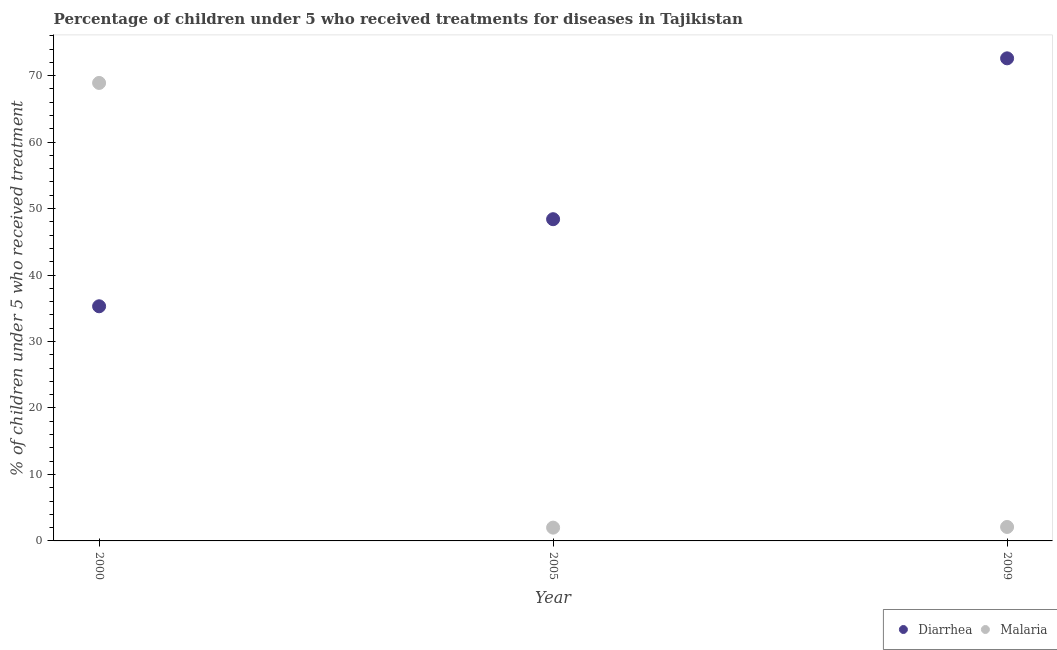What is the percentage of children who received treatment for malaria in 2009?
Keep it short and to the point. 2.1. Across all years, what is the maximum percentage of children who received treatment for diarrhoea?
Your answer should be very brief. 72.6. Across all years, what is the minimum percentage of children who received treatment for diarrhoea?
Keep it short and to the point. 35.3. In which year was the percentage of children who received treatment for diarrhoea minimum?
Ensure brevity in your answer.  2000. What is the total percentage of children who received treatment for diarrhoea in the graph?
Your answer should be compact. 156.3. What is the difference between the percentage of children who received treatment for diarrhoea in 2000 and that in 2009?
Your answer should be compact. -37.3. What is the difference between the percentage of children who received treatment for malaria in 2000 and the percentage of children who received treatment for diarrhoea in 2005?
Keep it short and to the point. 20.5. What is the average percentage of children who received treatment for malaria per year?
Give a very brief answer. 24.33. In the year 2009, what is the difference between the percentage of children who received treatment for malaria and percentage of children who received treatment for diarrhoea?
Offer a terse response. -70.5. What is the ratio of the percentage of children who received treatment for malaria in 2000 to that in 2005?
Keep it short and to the point. 34.45. Is the percentage of children who received treatment for malaria in 2000 less than that in 2005?
Give a very brief answer. No. What is the difference between the highest and the second highest percentage of children who received treatment for malaria?
Your response must be concise. 66.8. What is the difference between the highest and the lowest percentage of children who received treatment for malaria?
Your answer should be very brief. 66.9. Is the sum of the percentage of children who received treatment for diarrhoea in 2005 and 2009 greater than the maximum percentage of children who received treatment for malaria across all years?
Provide a succinct answer. Yes. Does the percentage of children who received treatment for diarrhoea monotonically increase over the years?
Ensure brevity in your answer.  Yes. Is the percentage of children who received treatment for malaria strictly greater than the percentage of children who received treatment for diarrhoea over the years?
Your answer should be very brief. No. How many dotlines are there?
Your response must be concise. 2. What is the difference between two consecutive major ticks on the Y-axis?
Provide a succinct answer. 10. How many legend labels are there?
Make the answer very short. 2. What is the title of the graph?
Offer a very short reply. Percentage of children under 5 who received treatments for diseases in Tajikistan. What is the label or title of the X-axis?
Offer a terse response. Year. What is the label or title of the Y-axis?
Your answer should be compact. % of children under 5 who received treatment. What is the % of children under 5 who received treatment of Diarrhea in 2000?
Keep it short and to the point. 35.3. What is the % of children under 5 who received treatment of Malaria in 2000?
Provide a short and direct response. 68.9. What is the % of children under 5 who received treatment in Diarrhea in 2005?
Your response must be concise. 48.4. What is the % of children under 5 who received treatment in Malaria in 2005?
Your answer should be very brief. 2. What is the % of children under 5 who received treatment of Diarrhea in 2009?
Offer a terse response. 72.6. What is the % of children under 5 who received treatment in Malaria in 2009?
Offer a terse response. 2.1. Across all years, what is the maximum % of children under 5 who received treatment of Diarrhea?
Give a very brief answer. 72.6. Across all years, what is the maximum % of children under 5 who received treatment in Malaria?
Provide a succinct answer. 68.9. Across all years, what is the minimum % of children under 5 who received treatment in Diarrhea?
Ensure brevity in your answer.  35.3. Across all years, what is the minimum % of children under 5 who received treatment of Malaria?
Provide a short and direct response. 2. What is the total % of children under 5 who received treatment in Diarrhea in the graph?
Provide a short and direct response. 156.3. What is the total % of children under 5 who received treatment in Malaria in the graph?
Offer a very short reply. 73. What is the difference between the % of children under 5 who received treatment in Diarrhea in 2000 and that in 2005?
Offer a very short reply. -13.1. What is the difference between the % of children under 5 who received treatment in Malaria in 2000 and that in 2005?
Make the answer very short. 66.9. What is the difference between the % of children under 5 who received treatment of Diarrhea in 2000 and that in 2009?
Offer a terse response. -37.3. What is the difference between the % of children under 5 who received treatment of Malaria in 2000 and that in 2009?
Ensure brevity in your answer.  66.8. What is the difference between the % of children under 5 who received treatment of Diarrhea in 2005 and that in 2009?
Keep it short and to the point. -24.2. What is the difference between the % of children under 5 who received treatment in Diarrhea in 2000 and the % of children under 5 who received treatment in Malaria in 2005?
Your answer should be very brief. 33.3. What is the difference between the % of children under 5 who received treatment in Diarrhea in 2000 and the % of children under 5 who received treatment in Malaria in 2009?
Give a very brief answer. 33.2. What is the difference between the % of children under 5 who received treatment of Diarrhea in 2005 and the % of children under 5 who received treatment of Malaria in 2009?
Your answer should be compact. 46.3. What is the average % of children under 5 who received treatment of Diarrhea per year?
Offer a terse response. 52.1. What is the average % of children under 5 who received treatment of Malaria per year?
Your answer should be compact. 24.33. In the year 2000, what is the difference between the % of children under 5 who received treatment of Diarrhea and % of children under 5 who received treatment of Malaria?
Your response must be concise. -33.6. In the year 2005, what is the difference between the % of children under 5 who received treatment of Diarrhea and % of children under 5 who received treatment of Malaria?
Give a very brief answer. 46.4. In the year 2009, what is the difference between the % of children under 5 who received treatment of Diarrhea and % of children under 5 who received treatment of Malaria?
Give a very brief answer. 70.5. What is the ratio of the % of children under 5 who received treatment of Diarrhea in 2000 to that in 2005?
Provide a short and direct response. 0.73. What is the ratio of the % of children under 5 who received treatment of Malaria in 2000 to that in 2005?
Make the answer very short. 34.45. What is the ratio of the % of children under 5 who received treatment in Diarrhea in 2000 to that in 2009?
Make the answer very short. 0.49. What is the ratio of the % of children under 5 who received treatment in Malaria in 2000 to that in 2009?
Give a very brief answer. 32.81. What is the ratio of the % of children under 5 who received treatment in Diarrhea in 2005 to that in 2009?
Your answer should be compact. 0.67. What is the ratio of the % of children under 5 who received treatment of Malaria in 2005 to that in 2009?
Ensure brevity in your answer.  0.95. What is the difference between the highest and the second highest % of children under 5 who received treatment in Diarrhea?
Your response must be concise. 24.2. What is the difference between the highest and the second highest % of children under 5 who received treatment of Malaria?
Your answer should be compact. 66.8. What is the difference between the highest and the lowest % of children under 5 who received treatment in Diarrhea?
Offer a terse response. 37.3. What is the difference between the highest and the lowest % of children under 5 who received treatment of Malaria?
Your answer should be very brief. 66.9. 